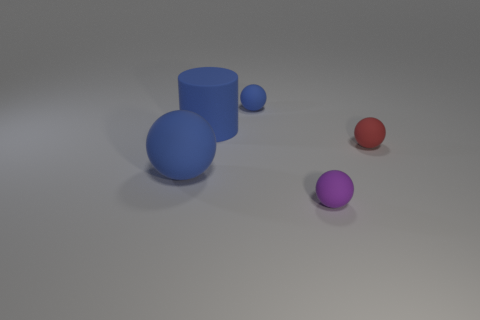Are there any blue rubber objects of the same size as the rubber cylinder?
Keep it short and to the point. Yes. The big cylinder is what color?
Make the answer very short. Blue. The sphere that is in front of the large blue object that is in front of the small red matte object is what color?
Your answer should be compact. Purple. There is a tiny rubber thing that is in front of the tiny red rubber thing that is behind the blue sphere that is on the left side of the small blue rubber object; what shape is it?
Provide a succinct answer. Sphere. What number of objects have the same material as the big cylinder?
Offer a very short reply. 4. There is a big object behind the large sphere; how many matte things are to the left of it?
Provide a succinct answer. 1. What number of tiny yellow spheres are there?
Your response must be concise. 0. Is the material of the tiny purple thing the same as the thing on the right side of the purple matte object?
Provide a succinct answer. Yes. Do the tiny thing right of the small purple object and the cylinder have the same color?
Offer a very short reply. No. The small object that is both behind the big ball and in front of the tiny blue object is made of what material?
Give a very brief answer. Rubber. 